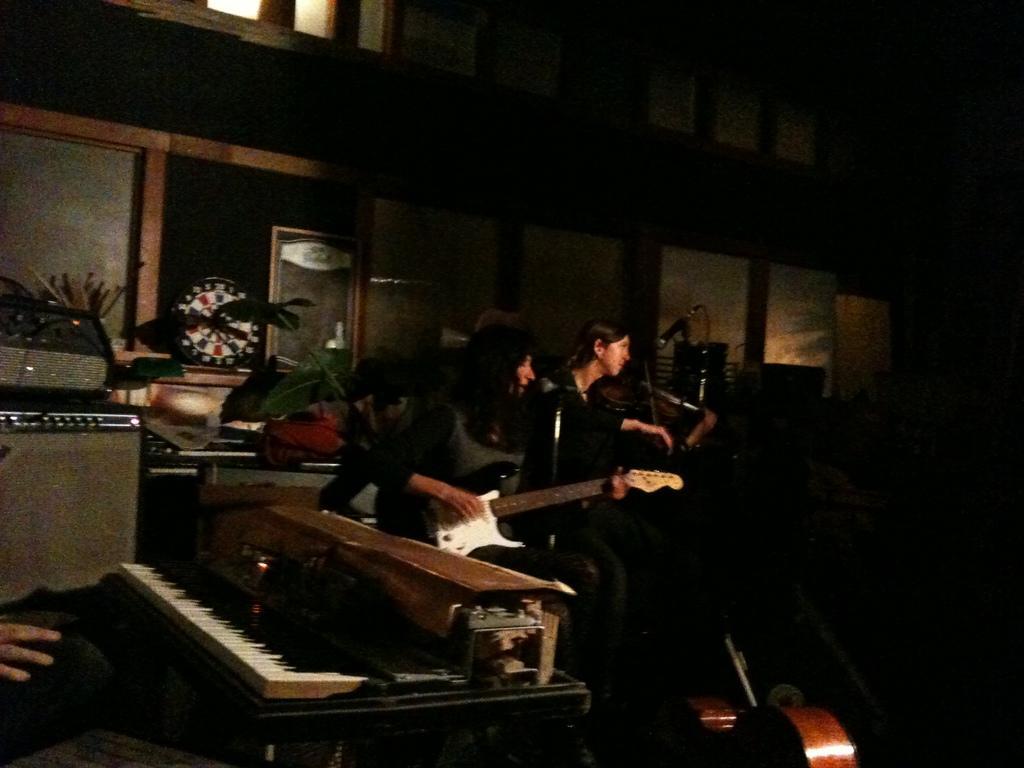Can you describe this image briefly? Here we can see two people sitting on a chair with microphone in front of them and they are having a guitar and they are playing the guitar and at the bottom left side we can see a piano, behind them there are some other musical instruments 